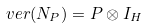<formula> <loc_0><loc_0><loc_500><loc_500>v e r ( N _ { P } ) = P \otimes I _ { H }</formula> 